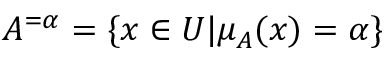Convert formula to latex. <formula><loc_0><loc_0><loc_500><loc_500>A ^ { = \alpha } = \{ x \in U | \mu _ { A } ( x ) = \alpha \}</formula> 